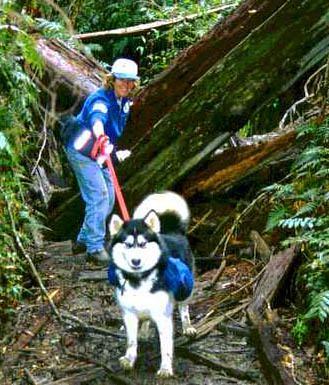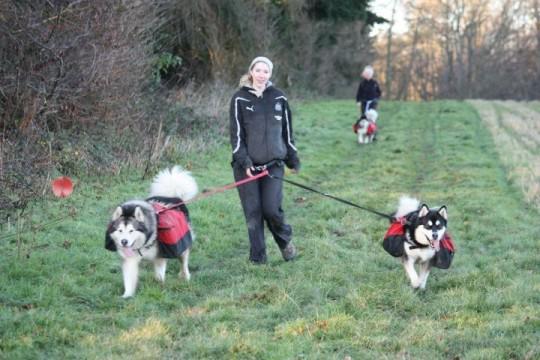The first image is the image on the left, the second image is the image on the right. Considering the images on both sides, is "At least one of the dogs does not have a backpack on its back." valid? Answer yes or no. No. The first image is the image on the left, the second image is the image on the right. Analyze the images presented: Is the assertion "In the left image, two furry dogs are seen wearing packs on their backs." valid? Answer yes or no. No. 